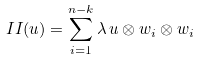<formula> <loc_0><loc_0><loc_500><loc_500>I I ( u ) = \sum _ { i = 1 } ^ { n - k } \lambda \, u \otimes w _ { i } \otimes w _ { i }</formula> 